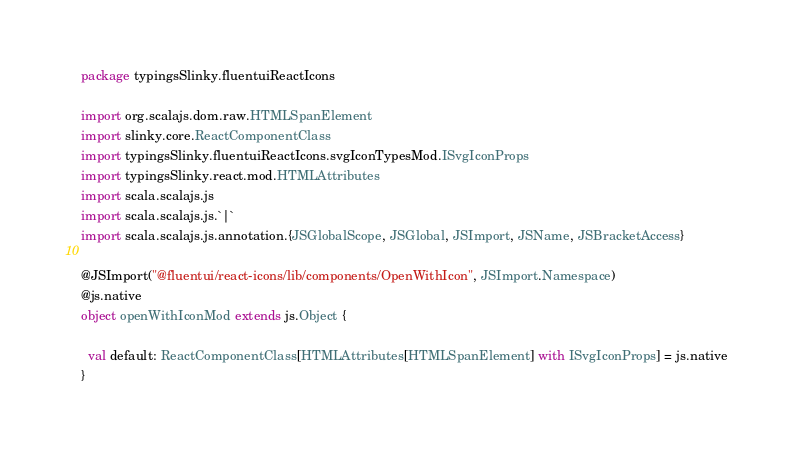Convert code to text. <code><loc_0><loc_0><loc_500><loc_500><_Scala_>package typingsSlinky.fluentuiReactIcons

import org.scalajs.dom.raw.HTMLSpanElement
import slinky.core.ReactComponentClass
import typingsSlinky.fluentuiReactIcons.svgIconTypesMod.ISvgIconProps
import typingsSlinky.react.mod.HTMLAttributes
import scala.scalajs.js
import scala.scalajs.js.`|`
import scala.scalajs.js.annotation.{JSGlobalScope, JSGlobal, JSImport, JSName, JSBracketAccess}

@JSImport("@fluentui/react-icons/lib/components/OpenWithIcon", JSImport.Namespace)
@js.native
object openWithIconMod extends js.Object {
  
  val default: ReactComponentClass[HTMLAttributes[HTMLSpanElement] with ISvgIconProps] = js.native
}
</code> 